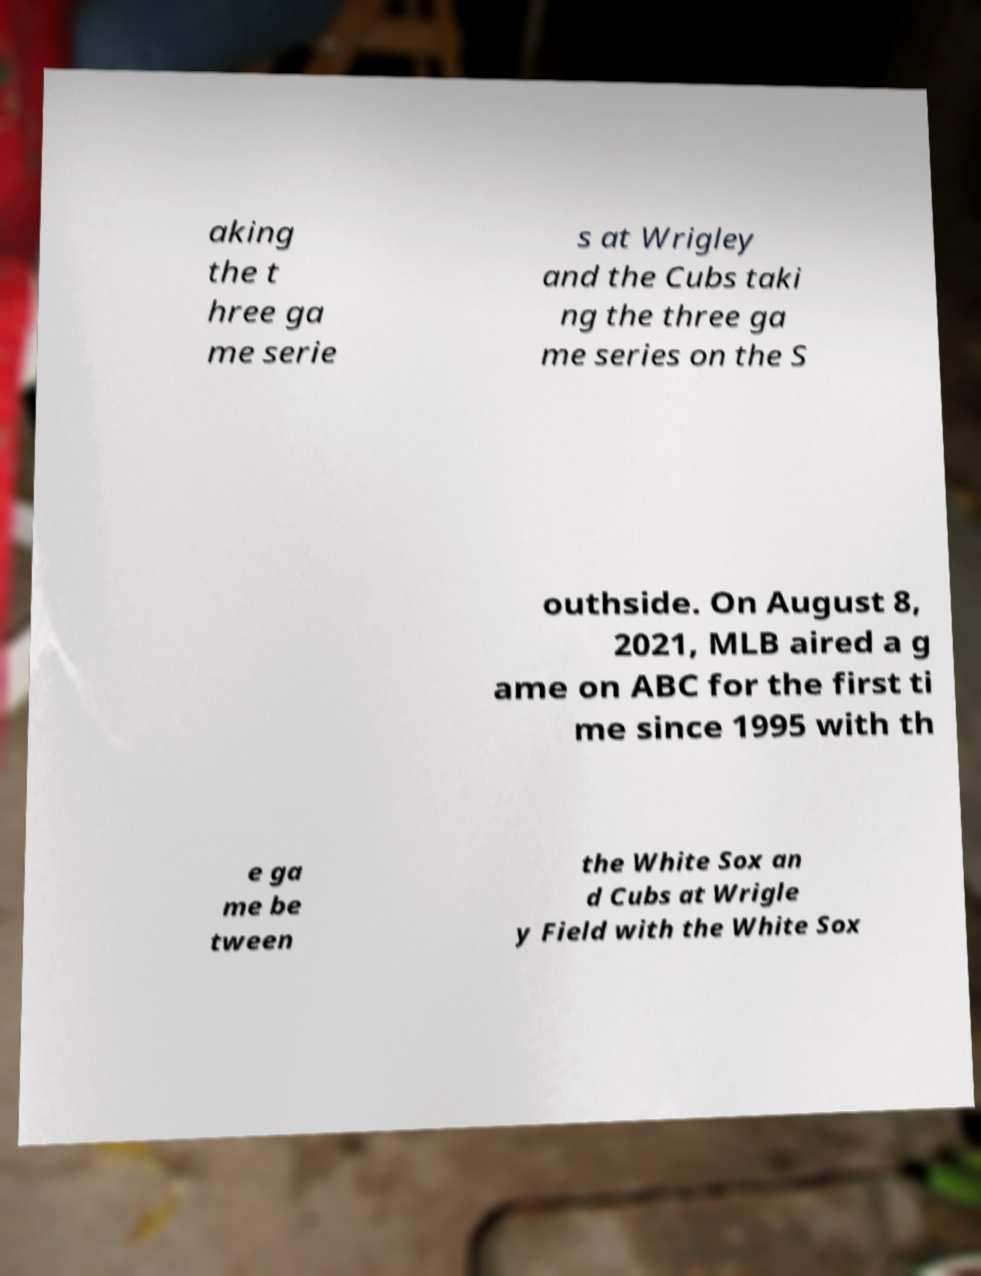Please identify and transcribe the text found in this image. aking the t hree ga me serie s at Wrigley and the Cubs taki ng the three ga me series on the S outhside. On August 8, 2021, MLB aired a g ame on ABC for the first ti me since 1995 with th e ga me be tween the White Sox an d Cubs at Wrigle y Field with the White Sox 